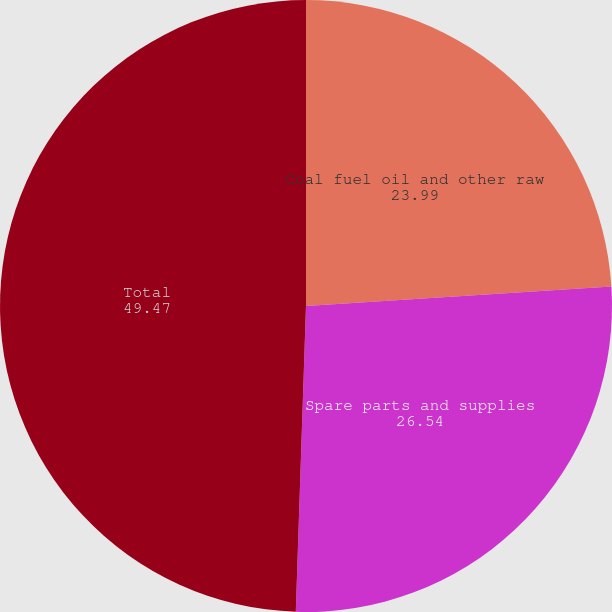Convert chart to OTSL. <chart><loc_0><loc_0><loc_500><loc_500><pie_chart><fcel>Coal fuel oil and other raw<fcel>Spare parts and supplies<fcel>Total<nl><fcel>23.99%<fcel>26.54%<fcel>49.47%<nl></chart> 